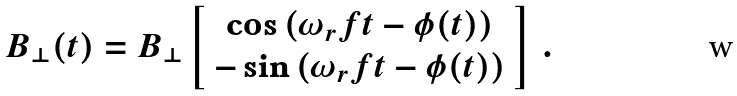Convert formula to latex. <formula><loc_0><loc_0><loc_500><loc_500>B _ { \bot } ( t ) = B _ { \bot } \left [ \begin{array} { c } \cos \left ( \omega _ { r } f t - \phi ( t ) \right ) \\ - \sin \left ( \omega _ { r } f t - \phi ( t ) \right ) \end{array} \right ] \, .</formula> 